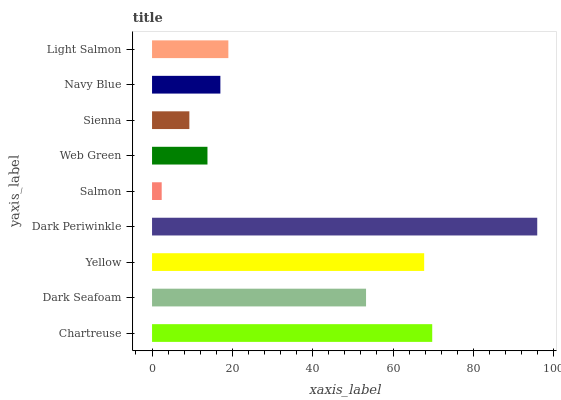Is Salmon the minimum?
Answer yes or no. Yes. Is Dark Periwinkle the maximum?
Answer yes or no. Yes. Is Dark Seafoam the minimum?
Answer yes or no. No. Is Dark Seafoam the maximum?
Answer yes or no. No. Is Chartreuse greater than Dark Seafoam?
Answer yes or no. Yes. Is Dark Seafoam less than Chartreuse?
Answer yes or no. Yes. Is Dark Seafoam greater than Chartreuse?
Answer yes or no. No. Is Chartreuse less than Dark Seafoam?
Answer yes or no. No. Is Light Salmon the high median?
Answer yes or no. Yes. Is Light Salmon the low median?
Answer yes or no. Yes. Is Dark Periwinkle the high median?
Answer yes or no. No. Is Yellow the low median?
Answer yes or no. No. 